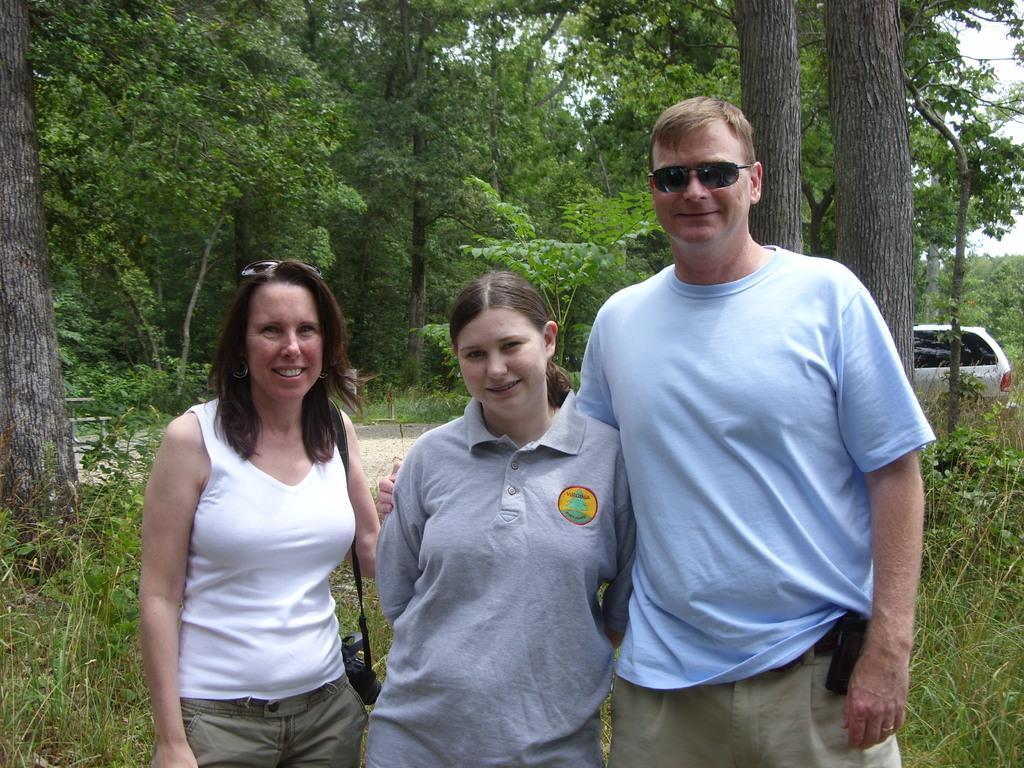How would you summarize this image in a sentence or two? In the foreground of the picture there are three people standing. In the center of the picture there are plants, trees, path and a car. In the background there are trees, grass, plants and sky. 